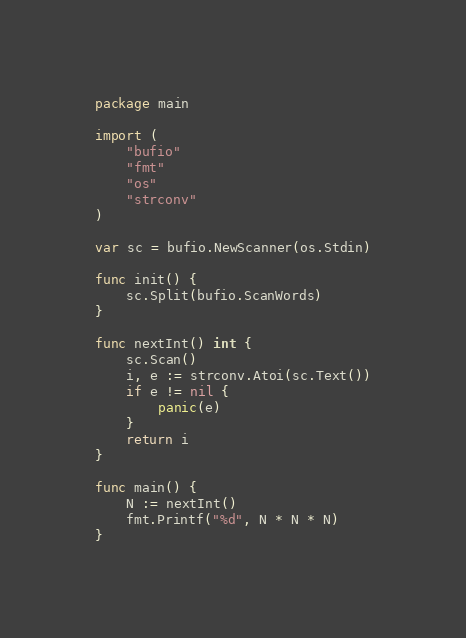<code> <loc_0><loc_0><loc_500><loc_500><_Go_>package main

import (
	"bufio"
	"fmt"
	"os"
	"strconv"
)

var sc = bufio.NewScanner(os.Stdin)

func init() {
	sc.Split(bufio.ScanWords)
}

func nextInt() int {
	sc.Scan()
	i, e := strconv.Atoi(sc.Text())
	if e != nil {
		panic(e)
	}
	return i
}

func main() {
	N := nextInt()
	fmt.Printf("%d", N * N * N)
}
</code> 